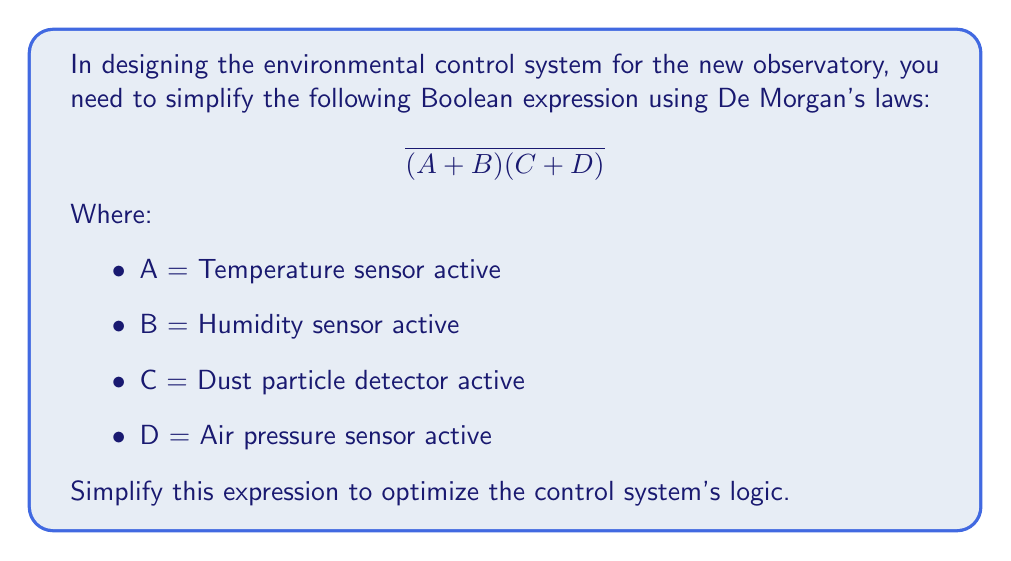Show me your answer to this math problem. To simplify this Boolean expression using De Morgan's laws, we'll follow these steps:

1. Recall De Morgan's laws:
   $\overline{X + Y} = \overline{X} \cdot \overline{Y}$
   $\overline{X \cdot Y} = \overline{X} + \overline{Y}$

2. Apply De Morgan's law to the entire expression:
   $\overline{(A + B)(C + D)} = \overline{(A + B)} + \overline{(C + D)}$

3. Now apply De Morgan's law to each part separately:
   $= (\overline{A} \cdot \overline{B}) + (\overline{C} \cdot \overline{D})$

4. This is the simplified expression. It means that the control system will activate when:
   - Either the temperature AND humidity sensors are NOT active
   - OR the dust particle detector AND air pressure sensor are NOT active

This simplification reduces the complexity of the logic gates required in the control system, potentially leading to a more efficient and cost-effective design for the observatory's environmental control.
Answer: $(\overline{A} \cdot \overline{B}) + (\overline{C} \cdot \overline{D})$ 